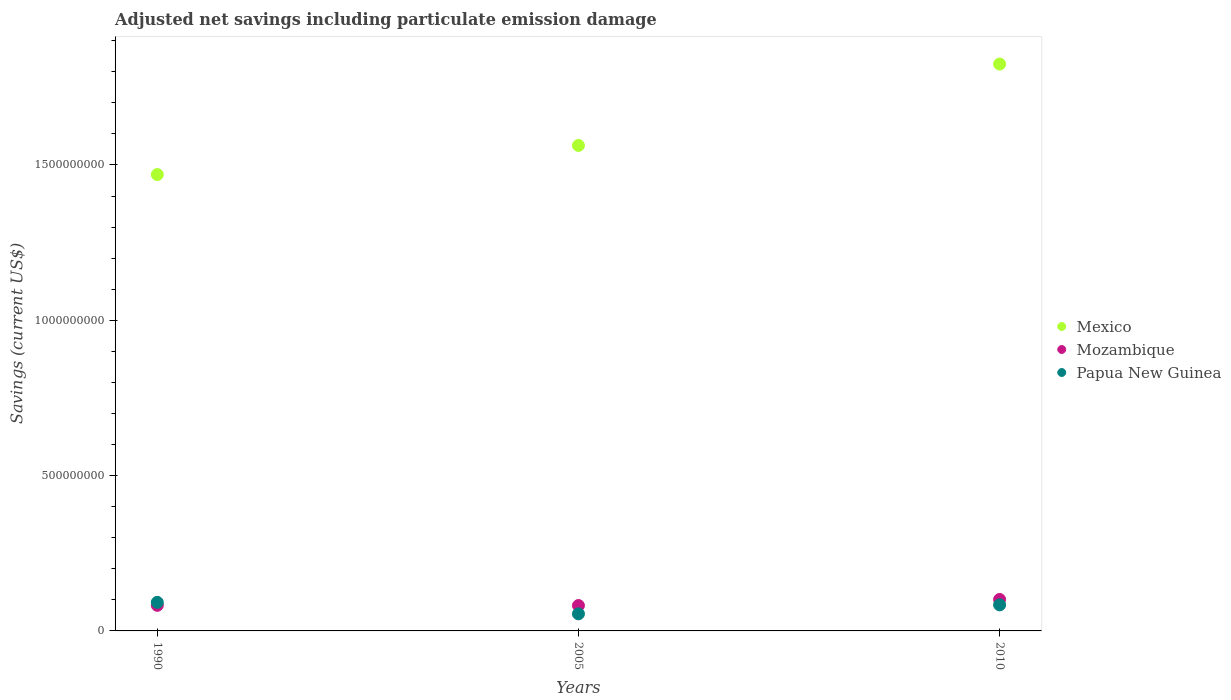What is the net savings in Papua New Guinea in 2010?
Provide a short and direct response. 8.39e+07. Across all years, what is the maximum net savings in Mozambique?
Offer a terse response. 1.01e+08. Across all years, what is the minimum net savings in Mozambique?
Provide a short and direct response. 8.17e+07. In which year was the net savings in Mozambique minimum?
Offer a terse response. 2005. What is the total net savings in Mozambique in the graph?
Keep it short and to the point. 2.65e+08. What is the difference between the net savings in Papua New Guinea in 1990 and that in 2010?
Give a very brief answer. 8.09e+06. What is the difference between the net savings in Mexico in 1990 and the net savings in Papua New Guinea in 2005?
Ensure brevity in your answer.  1.41e+09. What is the average net savings in Mozambique per year?
Ensure brevity in your answer.  8.85e+07. In the year 2010, what is the difference between the net savings in Papua New Guinea and net savings in Mexico?
Your answer should be compact. -1.74e+09. In how many years, is the net savings in Papua New Guinea greater than 200000000 US$?
Offer a very short reply. 0. What is the ratio of the net savings in Papua New Guinea in 2005 to that in 2010?
Give a very brief answer. 0.66. Is the net savings in Mexico in 2005 less than that in 2010?
Your answer should be compact. Yes. Is the difference between the net savings in Papua New Guinea in 1990 and 2010 greater than the difference between the net savings in Mexico in 1990 and 2010?
Ensure brevity in your answer.  Yes. What is the difference between the highest and the second highest net savings in Papua New Guinea?
Provide a short and direct response. 8.09e+06. What is the difference between the highest and the lowest net savings in Mozambique?
Make the answer very short. 1.96e+07. Is the sum of the net savings in Mozambique in 2005 and 2010 greater than the maximum net savings in Papua New Guinea across all years?
Keep it short and to the point. Yes. Is it the case that in every year, the sum of the net savings in Papua New Guinea and net savings in Mexico  is greater than the net savings in Mozambique?
Offer a very short reply. Yes. Does the net savings in Papua New Guinea monotonically increase over the years?
Your answer should be very brief. No. How many dotlines are there?
Your response must be concise. 3. What is the difference between two consecutive major ticks on the Y-axis?
Your answer should be compact. 5.00e+08. Are the values on the major ticks of Y-axis written in scientific E-notation?
Offer a terse response. No. Does the graph contain grids?
Offer a very short reply. No. Where does the legend appear in the graph?
Your answer should be compact. Center right. What is the title of the graph?
Your response must be concise. Adjusted net savings including particulate emission damage. What is the label or title of the X-axis?
Offer a terse response. Years. What is the label or title of the Y-axis?
Your response must be concise. Savings (current US$). What is the Savings (current US$) in Mexico in 1990?
Provide a short and direct response. 1.47e+09. What is the Savings (current US$) of Mozambique in 1990?
Ensure brevity in your answer.  8.24e+07. What is the Savings (current US$) in Papua New Guinea in 1990?
Keep it short and to the point. 9.20e+07. What is the Savings (current US$) of Mexico in 2005?
Give a very brief answer. 1.56e+09. What is the Savings (current US$) of Mozambique in 2005?
Offer a very short reply. 8.17e+07. What is the Savings (current US$) in Papua New Guinea in 2005?
Provide a short and direct response. 5.50e+07. What is the Savings (current US$) of Mexico in 2010?
Make the answer very short. 1.82e+09. What is the Savings (current US$) in Mozambique in 2010?
Provide a short and direct response. 1.01e+08. What is the Savings (current US$) of Papua New Guinea in 2010?
Your answer should be very brief. 8.39e+07. Across all years, what is the maximum Savings (current US$) of Mexico?
Provide a succinct answer. 1.82e+09. Across all years, what is the maximum Savings (current US$) in Mozambique?
Your answer should be very brief. 1.01e+08. Across all years, what is the maximum Savings (current US$) in Papua New Guinea?
Provide a succinct answer. 9.20e+07. Across all years, what is the minimum Savings (current US$) in Mexico?
Keep it short and to the point. 1.47e+09. Across all years, what is the minimum Savings (current US$) of Mozambique?
Your response must be concise. 8.17e+07. Across all years, what is the minimum Savings (current US$) of Papua New Guinea?
Provide a succinct answer. 5.50e+07. What is the total Savings (current US$) of Mexico in the graph?
Your answer should be very brief. 4.86e+09. What is the total Savings (current US$) of Mozambique in the graph?
Make the answer very short. 2.65e+08. What is the total Savings (current US$) of Papua New Guinea in the graph?
Give a very brief answer. 2.31e+08. What is the difference between the Savings (current US$) of Mexico in 1990 and that in 2005?
Your answer should be very brief. -9.37e+07. What is the difference between the Savings (current US$) in Mozambique in 1990 and that in 2005?
Offer a very short reply. 6.39e+05. What is the difference between the Savings (current US$) of Papua New Guinea in 1990 and that in 2005?
Offer a terse response. 3.70e+07. What is the difference between the Savings (current US$) of Mexico in 1990 and that in 2010?
Your response must be concise. -3.56e+08. What is the difference between the Savings (current US$) of Mozambique in 1990 and that in 2010?
Your answer should be very brief. -1.90e+07. What is the difference between the Savings (current US$) of Papua New Guinea in 1990 and that in 2010?
Your answer should be compact. 8.09e+06. What is the difference between the Savings (current US$) in Mexico in 2005 and that in 2010?
Keep it short and to the point. -2.62e+08. What is the difference between the Savings (current US$) in Mozambique in 2005 and that in 2010?
Offer a very short reply. -1.96e+07. What is the difference between the Savings (current US$) of Papua New Guinea in 2005 and that in 2010?
Make the answer very short. -2.89e+07. What is the difference between the Savings (current US$) of Mexico in 1990 and the Savings (current US$) of Mozambique in 2005?
Ensure brevity in your answer.  1.39e+09. What is the difference between the Savings (current US$) in Mexico in 1990 and the Savings (current US$) in Papua New Guinea in 2005?
Provide a succinct answer. 1.41e+09. What is the difference between the Savings (current US$) in Mozambique in 1990 and the Savings (current US$) in Papua New Guinea in 2005?
Your answer should be compact. 2.73e+07. What is the difference between the Savings (current US$) in Mexico in 1990 and the Savings (current US$) in Mozambique in 2010?
Your answer should be very brief. 1.37e+09. What is the difference between the Savings (current US$) in Mexico in 1990 and the Savings (current US$) in Papua New Guinea in 2010?
Your answer should be compact. 1.39e+09. What is the difference between the Savings (current US$) in Mozambique in 1990 and the Savings (current US$) in Papua New Guinea in 2010?
Ensure brevity in your answer.  -1.53e+06. What is the difference between the Savings (current US$) in Mexico in 2005 and the Savings (current US$) in Mozambique in 2010?
Provide a succinct answer. 1.46e+09. What is the difference between the Savings (current US$) in Mexico in 2005 and the Savings (current US$) in Papua New Guinea in 2010?
Give a very brief answer. 1.48e+09. What is the difference between the Savings (current US$) of Mozambique in 2005 and the Savings (current US$) of Papua New Guinea in 2010?
Give a very brief answer. -2.17e+06. What is the average Savings (current US$) in Mexico per year?
Your answer should be very brief. 1.62e+09. What is the average Savings (current US$) of Mozambique per year?
Offer a terse response. 8.85e+07. What is the average Savings (current US$) in Papua New Guinea per year?
Keep it short and to the point. 7.70e+07. In the year 1990, what is the difference between the Savings (current US$) of Mexico and Savings (current US$) of Mozambique?
Give a very brief answer. 1.39e+09. In the year 1990, what is the difference between the Savings (current US$) in Mexico and Savings (current US$) in Papua New Guinea?
Your answer should be very brief. 1.38e+09. In the year 1990, what is the difference between the Savings (current US$) in Mozambique and Savings (current US$) in Papua New Guinea?
Ensure brevity in your answer.  -9.62e+06. In the year 2005, what is the difference between the Savings (current US$) of Mexico and Savings (current US$) of Mozambique?
Make the answer very short. 1.48e+09. In the year 2005, what is the difference between the Savings (current US$) of Mexico and Savings (current US$) of Papua New Guinea?
Your answer should be compact. 1.51e+09. In the year 2005, what is the difference between the Savings (current US$) in Mozambique and Savings (current US$) in Papua New Guinea?
Your response must be concise. 2.67e+07. In the year 2010, what is the difference between the Savings (current US$) of Mexico and Savings (current US$) of Mozambique?
Give a very brief answer. 1.72e+09. In the year 2010, what is the difference between the Savings (current US$) of Mexico and Savings (current US$) of Papua New Guinea?
Provide a short and direct response. 1.74e+09. In the year 2010, what is the difference between the Savings (current US$) of Mozambique and Savings (current US$) of Papua New Guinea?
Keep it short and to the point. 1.74e+07. What is the ratio of the Savings (current US$) of Mexico in 1990 to that in 2005?
Provide a succinct answer. 0.94. What is the ratio of the Savings (current US$) of Papua New Guinea in 1990 to that in 2005?
Your answer should be very brief. 1.67. What is the ratio of the Savings (current US$) of Mexico in 1990 to that in 2010?
Give a very brief answer. 0.81. What is the ratio of the Savings (current US$) of Mozambique in 1990 to that in 2010?
Give a very brief answer. 0.81. What is the ratio of the Savings (current US$) of Papua New Guinea in 1990 to that in 2010?
Your response must be concise. 1.1. What is the ratio of the Savings (current US$) of Mexico in 2005 to that in 2010?
Give a very brief answer. 0.86. What is the ratio of the Savings (current US$) in Mozambique in 2005 to that in 2010?
Offer a very short reply. 0.81. What is the ratio of the Savings (current US$) of Papua New Guinea in 2005 to that in 2010?
Make the answer very short. 0.66. What is the difference between the highest and the second highest Savings (current US$) in Mexico?
Keep it short and to the point. 2.62e+08. What is the difference between the highest and the second highest Savings (current US$) of Mozambique?
Make the answer very short. 1.90e+07. What is the difference between the highest and the second highest Savings (current US$) of Papua New Guinea?
Offer a very short reply. 8.09e+06. What is the difference between the highest and the lowest Savings (current US$) in Mexico?
Offer a terse response. 3.56e+08. What is the difference between the highest and the lowest Savings (current US$) of Mozambique?
Ensure brevity in your answer.  1.96e+07. What is the difference between the highest and the lowest Savings (current US$) of Papua New Guinea?
Ensure brevity in your answer.  3.70e+07. 